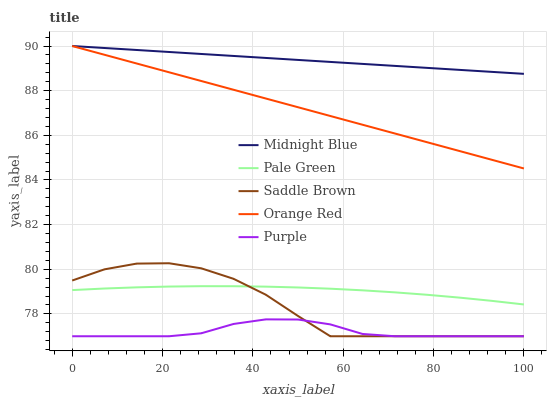Does Purple have the minimum area under the curve?
Answer yes or no. Yes. Does Midnight Blue have the maximum area under the curve?
Answer yes or no. Yes. Does Pale Green have the minimum area under the curve?
Answer yes or no. No. Does Pale Green have the maximum area under the curve?
Answer yes or no. No. Is Midnight Blue the smoothest?
Answer yes or no. Yes. Is Saddle Brown the roughest?
Answer yes or no. Yes. Is Pale Green the smoothest?
Answer yes or no. No. Is Pale Green the roughest?
Answer yes or no. No. Does Purple have the lowest value?
Answer yes or no. Yes. Does Pale Green have the lowest value?
Answer yes or no. No. Does Orange Red have the highest value?
Answer yes or no. Yes. Does Pale Green have the highest value?
Answer yes or no. No. Is Purple less than Midnight Blue?
Answer yes or no. Yes. Is Midnight Blue greater than Saddle Brown?
Answer yes or no. Yes. Does Saddle Brown intersect Purple?
Answer yes or no. Yes. Is Saddle Brown less than Purple?
Answer yes or no. No. Is Saddle Brown greater than Purple?
Answer yes or no. No. Does Purple intersect Midnight Blue?
Answer yes or no. No. 